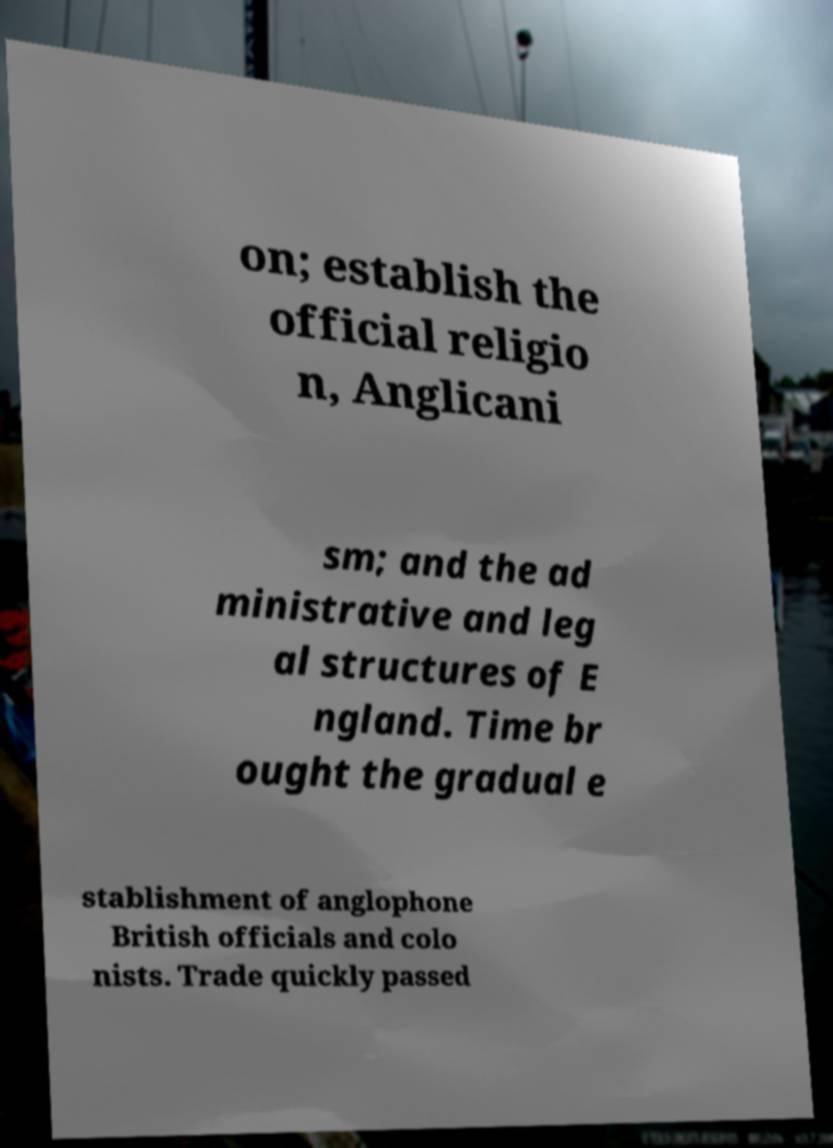Please read and relay the text visible in this image. What does it say? on; establish the official religio n, Anglicani sm; and the ad ministrative and leg al structures of E ngland. Time br ought the gradual e stablishment of anglophone British officials and colo nists. Trade quickly passed 